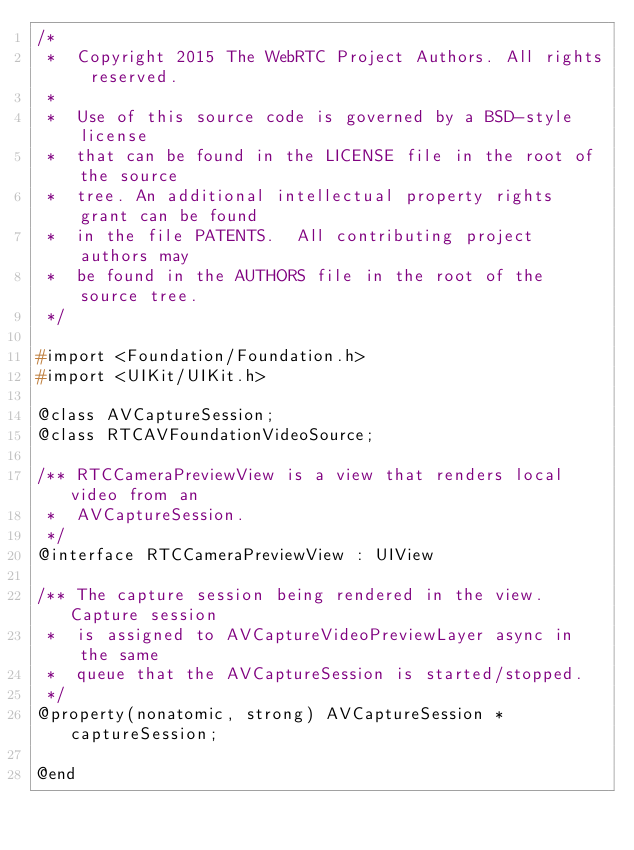<code> <loc_0><loc_0><loc_500><loc_500><_C_>/*
 *  Copyright 2015 The WebRTC Project Authors. All rights reserved.
 *
 *  Use of this source code is governed by a BSD-style license
 *  that can be found in the LICENSE file in the root of the source
 *  tree. An additional intellectual property rights grant can be found
 *  in the file PATENTS.  All contributing project authors may
 *  be found in the AUTHORS file in the root of the source tree.
 */

#import <Foundation/Foundation.h>
#import <UIKit/UIKit.h>

@class AVCaptureSession;
@class RTCAVFoundationVideoSource;

/** RTCCameraPreviewView is a view that renders local video from an
 *  AVCaptureSession.
 */
@interface RTCCameraPreviewView : UIView

/** The capture session being rendered in the view. Capture session
 *  is assigned to AVCaptureVideoPreviewLayer async in the same
 *  queue that the AVCaptureSession is started/stopped.
 */
@property(nonatomic, strong) AVCaptureSession *captureSession;

@end
</code> 